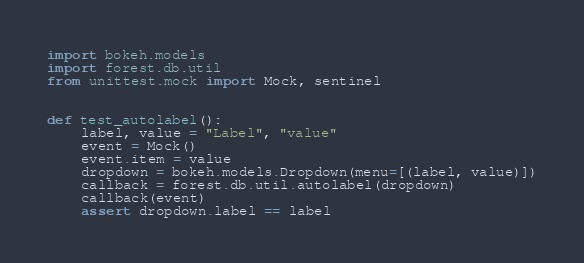<code> <loc_0><loc_0><loc_500><loc_500><_Python_>import bokeh.models
import forest.db.util
from unittest.mock import Mock, sentinel


def test_autolabel():
    label, value = "Label", "value"
    event = Mock()
    event.item = value
    dropdown = bokeh.models.Dropdown(menu=[(label, value)])
    callback = forest.db.util.autolabel(dropdown)
    callback(event)
    assert dropdown.label == label
</code> 